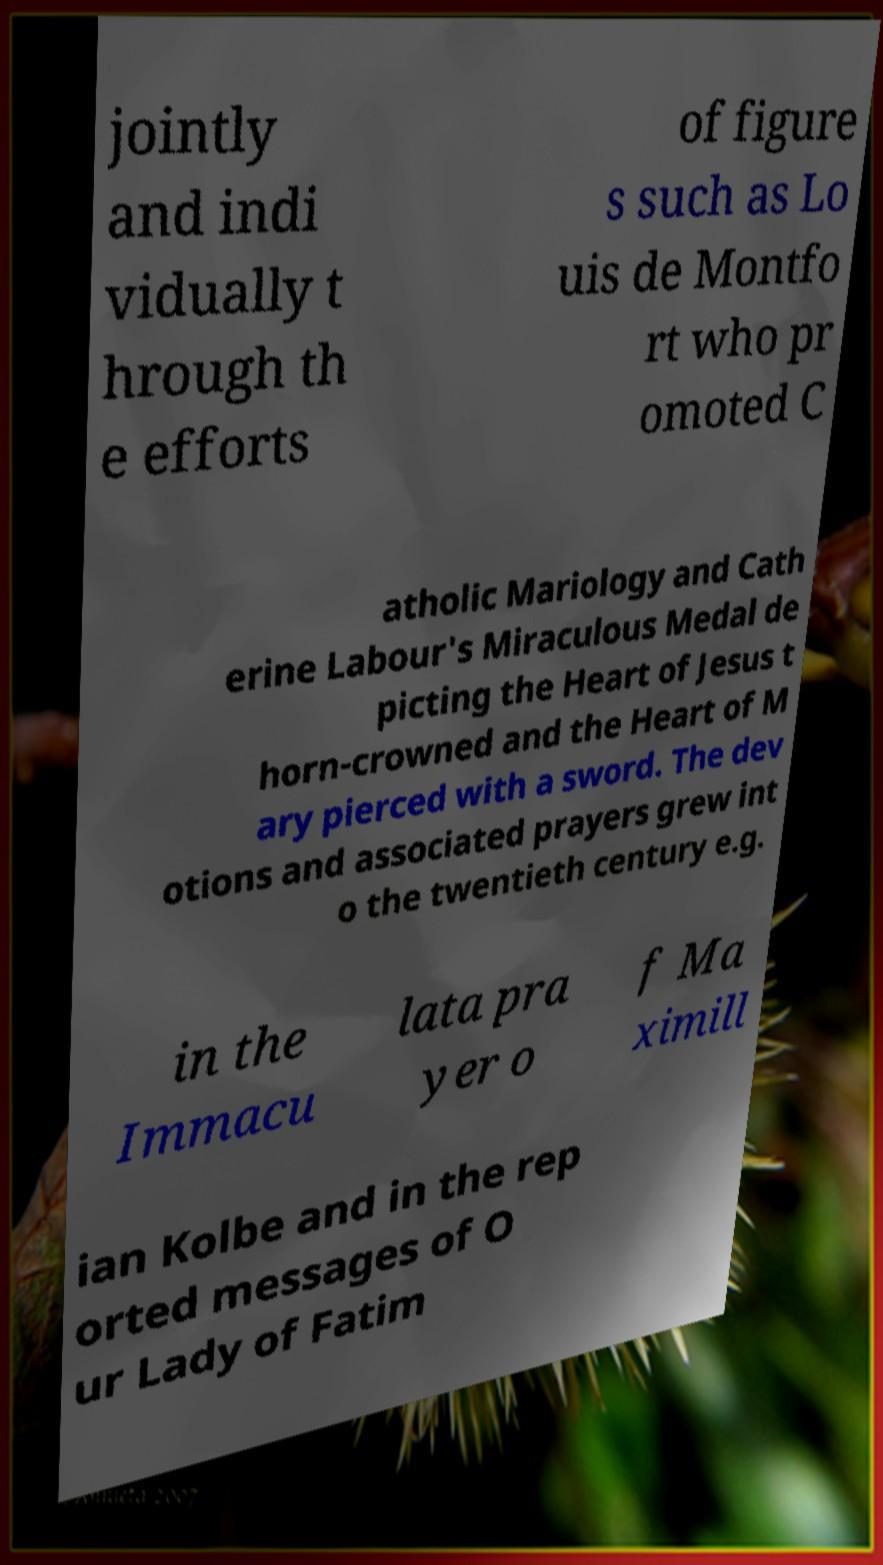Please read and relay the text visible in this image. What does it say? jointly and indi vidually t hrough th e efforts of figure s such as Lo uis de Montfo rt who pr omoted C atholic Mariology and Cath erine Labour's Miraculous Medal de picting the Heart of Jesus t horn-crowned and the Heart of M ary pierced with a sword. The dev otions and associated prayers grew int o the twentieth century e.g. in the Immacu lata pra yer o f Ma ximill ian Kolbe and in the rep orted messages of O ur Lady of Fatim 